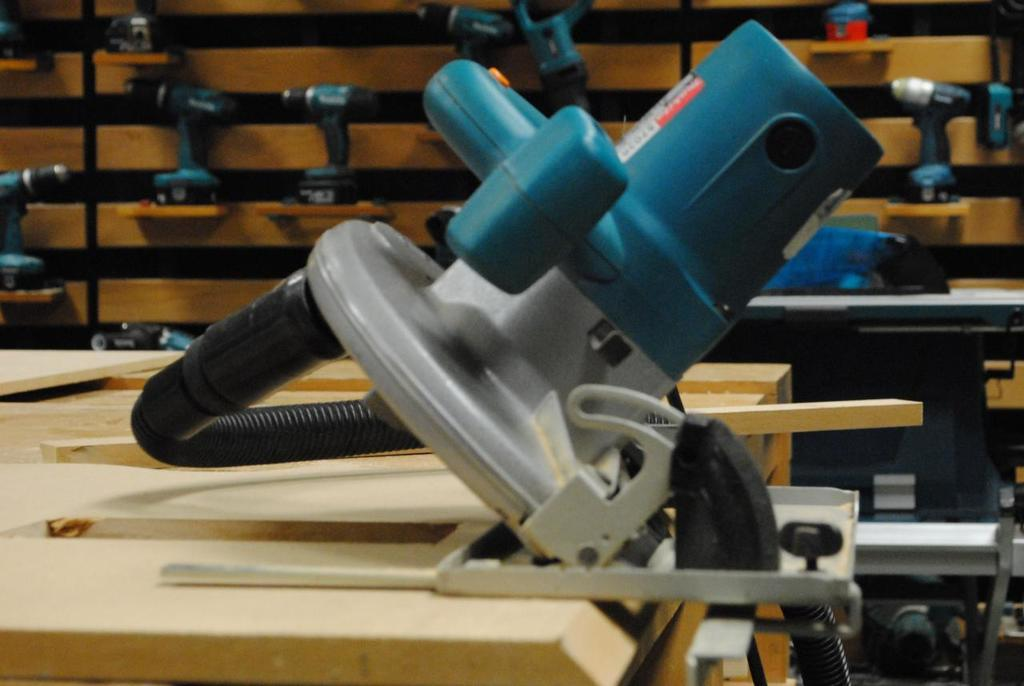What type of furniture is present in the image? There are tables in the image. What other objects can be seen in the image besides the tables? There is machinery in the image. What is the color of the machinery? The machinery is in blue color. What type of silk is being used to cover the machinery in the image? There is no silk present in the image; the machinery is in blue color. 